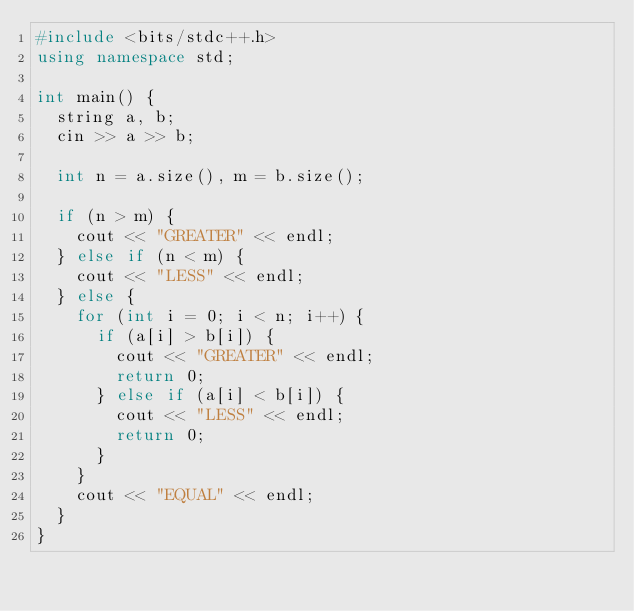Convert code to text. <code><loc_0><loc_0><loc_500><loc_500><_C++_>#include <bits/stdc++.h>
using namespace std;

int main() {
  string a, b;
  cin >> a >> b;

  int n = a.size(), m = b.size();

  if (n > m) {
    cout << "GREATER" << endl;
  } else if (n < m) {
    cout << "LESS" << endl;
  } else {
    for (int i = 0; i < n; i++) {
      if (a[i] > b[i]) {
        cout << "GREATER" << endl;
        return 0;
      } else if (a[i] < b[i]) {
        cout << "LESS" << endl;
        return 0;
      }
    }
    cout << "EQUAL" << endl;
  }
}</code> 